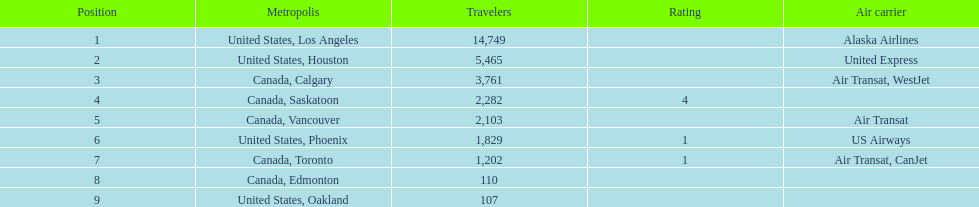Which canadian city had the most passengers traveling from manzanillo international airport in 2013? Calgary. 